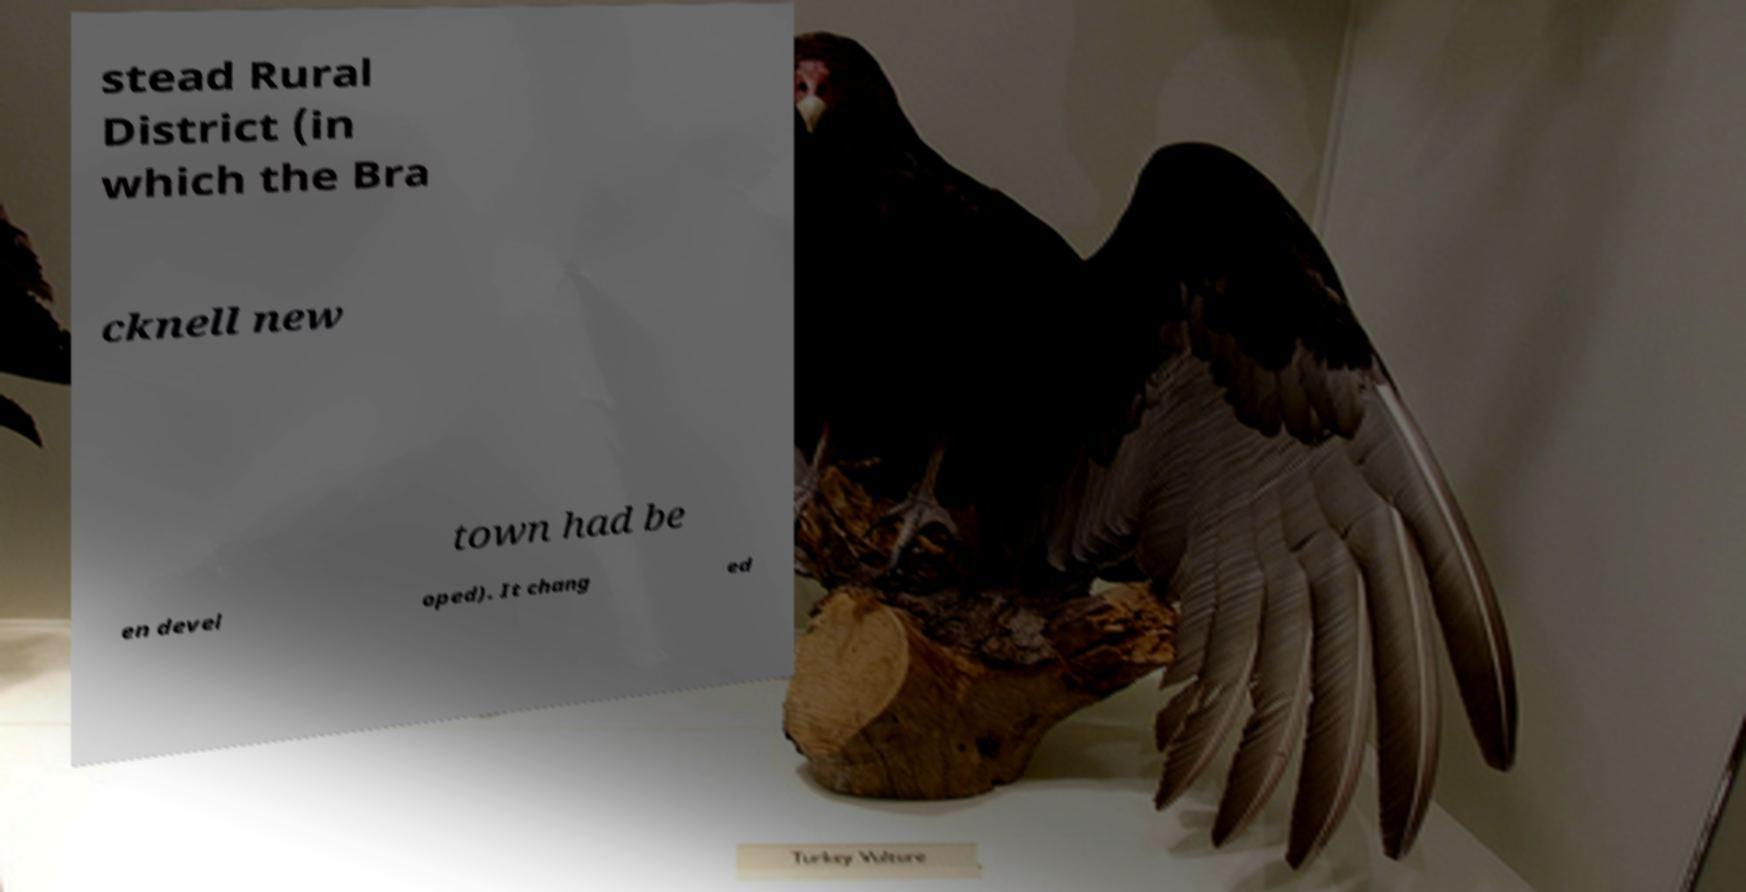Can you read and provide the text displayed in the image?This photo seems to have some interesting text. Can you extract and type it out for me? stead Rural District (in which the Bra cknell new town had be en devel oped). It chang ed 